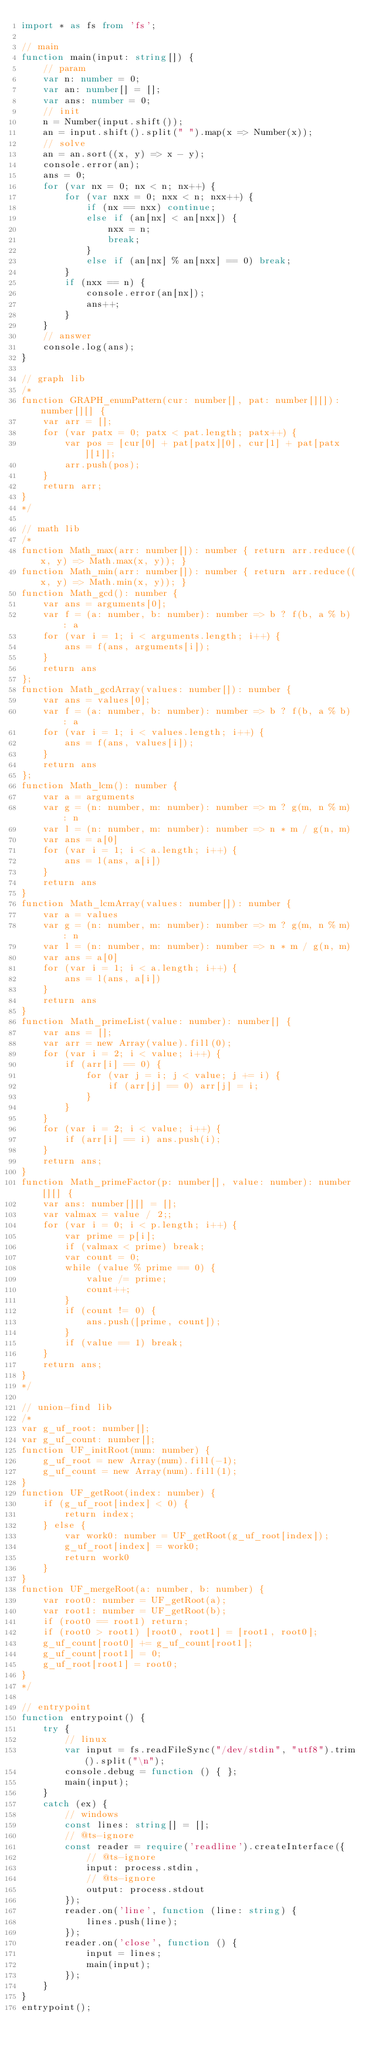Convert code to text. <code><loc_0><loc_0><loc_500><loc_500><_TypeScript_>import * as fs from 'fs';

// main
function main(input: string[]) {
    // param
    var n: number = 0;
    var an: number[] = [];
    var ans: number = 0;
    // init
    n = Number(input.shift());
    an = input.shift().split(" ").map(x => Number(x));
    // solve
    an = an.sort((x, y) => x - y);
    console.error(an);
    ans = 0;
    for (var nx = 0; nx < n; nx++) {
        for (var nxx = 0; nxx < n; nxx++) {
            if (nx == nxx) continue;
            else if (an[nx] < an[nxx]) {
                nxx = n;
                break;
            }
            else if (an[nx] % an[nxx] == 0) break;
        }
        if (nxx == n) {
            console.error(an[nx]);
            ans++;
        }
    }
    // answer
    console.log(ans);
}

// graph lib
/*
function GRAPH_enumPattern(cur: number[], pat: number[][]): number[][] {
    var arr = [];
    for (var patx = 0; patx < pat.length; patx++) {
        var pos = [cur[0] + pat[patx][0], cur[1] + pat[patx][1]];
        arr.push(pos);
    }
    return arr;
}
*/

// math lib
/*
function Math_max(arr: number[]): number { return arr.reduce((x, y) => Math.max(x, y)); }
function Math_min(arr: number[]): number { return arr.reduce((x, y) => Math.min(x, y)); }
function Math_gcd(): number {
    var ans = arguments[0];
    var f = (a: number, b: number): number => b ? f(b, a % b) : a
    for (var i = 1; i < arguments.length; i++) {
        ans = f(ans, arguments[i]);
    }
    return ans
};
function Math_gcdArray(values: number[]): number {
    var ans = values[0];
    var f = (a: number, b: number): number => b ? f(b, a % b) : a
    for (var i = 1; i < values.length; i++) {
        ans = f(ans, values[i]);
    }
    return ans
};
function Math_lcm(): number {
    var a = arguments
    var g = (n: number, m: number): number => m ? g(m, n % m) : n
    var l = (n: number, m: number): number => n * m / g(n, m)
    var ans = a[0]
    for (var i = 1; i < a.length; i++) {
        ans = l(ans, a[i])
    }
    return ans
}
function Math_lcmArray(values: number[]): number {
    var a = values
    var g = (n: number, m: number): number => m ? g(m, n % m) : n
    var l = (n: number, m: number): number => n * m / g(n, m)
    var ans = a[0]
    for (var i = 1; i < a.length; i++) {
        ans = l(ans, a[i])
    }
    return ans
}
function Math_primeList(value: number): number[] {
    var ans = [];
    var arr = new Array(value).fill(0);
    for (var i = 2; i < value; i++) {
        if (arr[i] == 0) {
            for (var j = i; j < value; j += i) {
                if (arr[j] == 0) arr[j] = i;
            }
        }
    }
    for (var i = 2; i < value; i++) {
        if (arr[i] == i) ans.push(i);
    }
    return ans;
}
function Math_primeFactor(p: number[], value: number): number[][] {
    var ans: number[][] = [];
    var valmax = value / 2;;
    for (var i = 0; i < p.length; i++) {
        var prime = p[i];
        if (valmax < prime) break;
        var count = 0;
        while (value % prime == 0) {
            value /= prime;
            count++;
        }
        if (count != 0) {
            ans.push([prime, count]);
        }
        if (value == 1) break;
    }
    return ans;
}
*/

// union-find lib
/*
var g_uf_root: number[];
var g_uf_count: number[];
function UF_initRoot(num: number) {
    g_uf_root = new Array(num).fill(-1);
    g_uf_count = new Array(num).fill(1);
}
function UF_getRoot(index: number) {
    if (g_uf_root[index] < 0) {
        return index;
    } else {
        var work0: number = UF_getRoot(g_uf_root[index]);
        g_uf_root[index] = work0;
        return work0
    }
}
function UF_mergeRoot(a: number, b: number) {
    var root0: number = UF_getRoot(a);
    var root1: number = UF_getRoot(b);
    if (root0 == root1) return;
    if (root0 > root1) [root0, root1] = [root1, root0];
    g_uf_count[root0] += g_uf_count[root1];
    g_uf_count[root1] = 0;
    g_uf_root[root1] = root0;
}
*/

// entrypoint
function entrypoint() {
    try {
        // linux
        var input = fs.readFileSync("/dev/stdin", "utf8").trim().split("\n");
        console.debug = function () { };
        main(input);
    }
    catch (ex) {
        // windows
        const lines: string[] = [];
        // @ts-ignore
        const reader = require('readline').createInterface({
            // @ts-ignore
            input: process.stdin,
            // @ts-ignore
            output: process.stdout
        });
        reader.on('line', function (line: string) {
            lines.push(line);
        });
        reader.on('close', function () {
            input = lines;
            main(input);
        });
    }
}
entrypoint();
</code> 